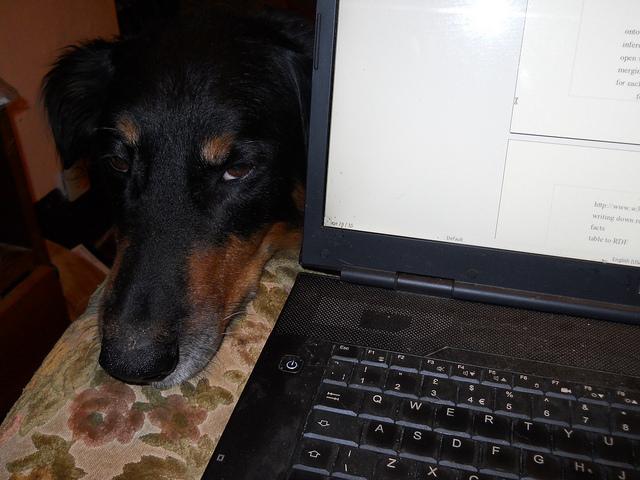What kind of animal is this?
Answer briefly. Dog. Is the laptop on or off?
Keep it brief. On. Does the dog want to learn how to type?
Short answer required. No. 